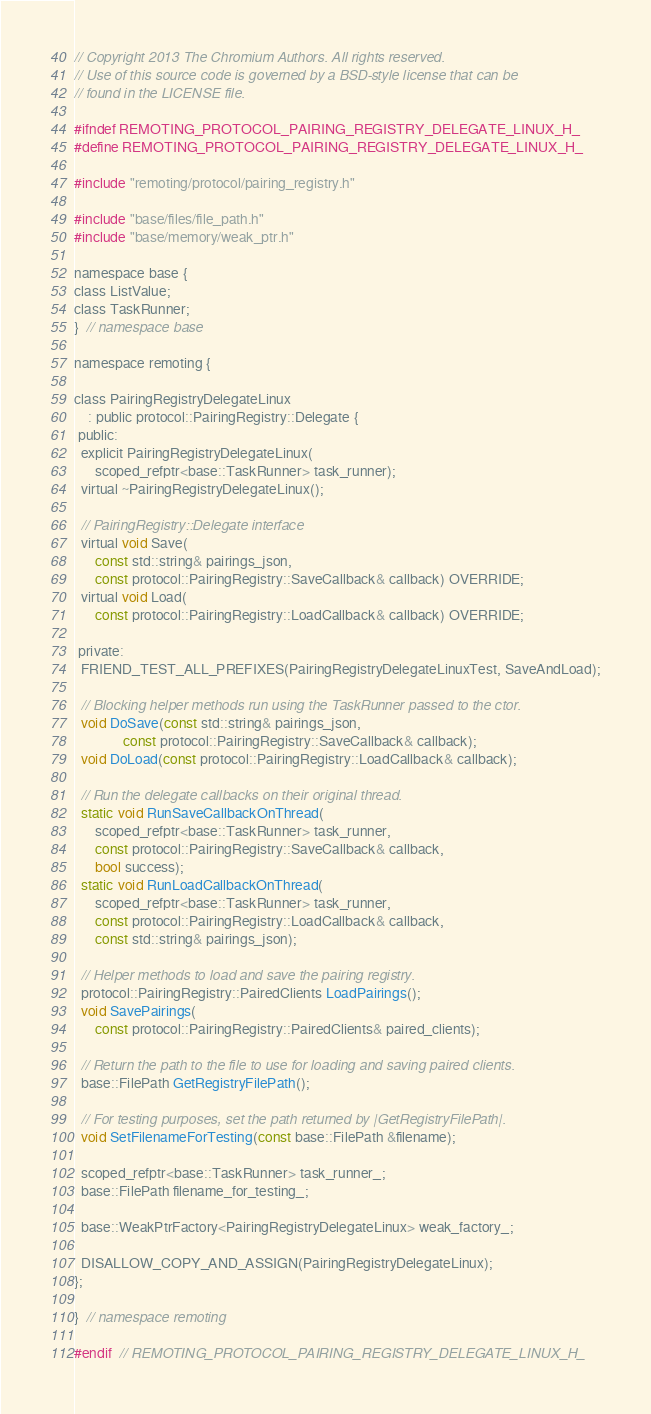<code> <loc_0><loc_0><loc_500><loc_500><_C_>// Copyright 2013 The Chromium Authors. All rights reserved.
// Use of this source code is governed by a BSD-style license that can be
// found in the LICENSE file.

#ifndef REMOTING_PROTOCOL_PAIRING_REGISTRY_DELEGATE_LINUX_H_
#define REMOTING_PROTOCOL_PAIRING_REGISTRY_DELEGATE_LINUX_H_

#include "remoting/protocol/pairing_registry.h"

#include "base/files/file_path.h"
#include "base/memory/weak_ptr.h"

namespace base {
class ListValue;
class TaskRunner;
}  // namespace base

namespace remoting {

class PairingRegistryDelegateLinux
    : public protocol::PairingRegistry::Delegate {
 public:
  explicit PairingRegistryDelegateLinux(
      scoped_refptr<base::TaskRunner> task_runner);
  virtual ~PairingRegistryDelegateLinux();

  // PairingRegistry::Delegate interface
  virtual void Save(
      const std::string& pairings_json,
      const protocol::PairingRegistry::SaveCallback& callback) OVERRIDE;
  virtual void Load(
      const protocol::PairingRegistry::LoadCallback& callback) OVERRIDE;

 private:
  FRIEND_TEST_ALL_PREFIXES(PairingRegistryDelegateLinuxTest, SaveAndLoad);

  // Blocking helper methods run using the TaskRunner passed to the ctor.
  void DoSave(const std::string& pairings_json,
              const protocol::PairingRegistry::SaveCallback& callback);
  void DoLoad(const protocol::PairingRegistry::LoadCallback& callback);

  // Run the delegate callbacks on their original thread.
  static void RunSaveCallbackOnThread(
      scoped_refptr<base::TaskRunner> task_runner,
      const protocol::PairingRegistry::SaveCallback& callback,
      bool success);
  static void RunLoadCallbackOnThread(
      scoped_refptr<base::TaskRunner> task_runner,
      const protocol::PairingRegistry::LoadCallback& callback,
      const std::string& pairings_json);

  // Helper methods to load and save the pairing registry.
  protocol::PairingRegistry::PairedClients LoadPairings();
  void SavePairings(
      const protocol::PairingRegistry::PairedClients& paired_clients);

  // Return the path to the file to use for loading and saving paired clients.
  base::FilePath GetRegistryFilePath();

  // For testing purposes, set the path returned by |GetRegistryFilePath|.
  void SetFilenameForTesting(const base::FilePath &filename);

  scoped_refptr<base::TaskRunner> task_runner_;
  base::FilePath filename_for_testing_;

  base::WeakPtrFactory<PairingRegistryDelegateLinux> weak_factory_;

  DISALLOW_COPY_AND_ASSIGN(PairingRegistryDelegateLinux);
};

}  // namespace remoting

#endif  // REMOTING_PROTOCOL_PAIRING_REGISTRY_DELEGATE_LINUX_H_
</code> 